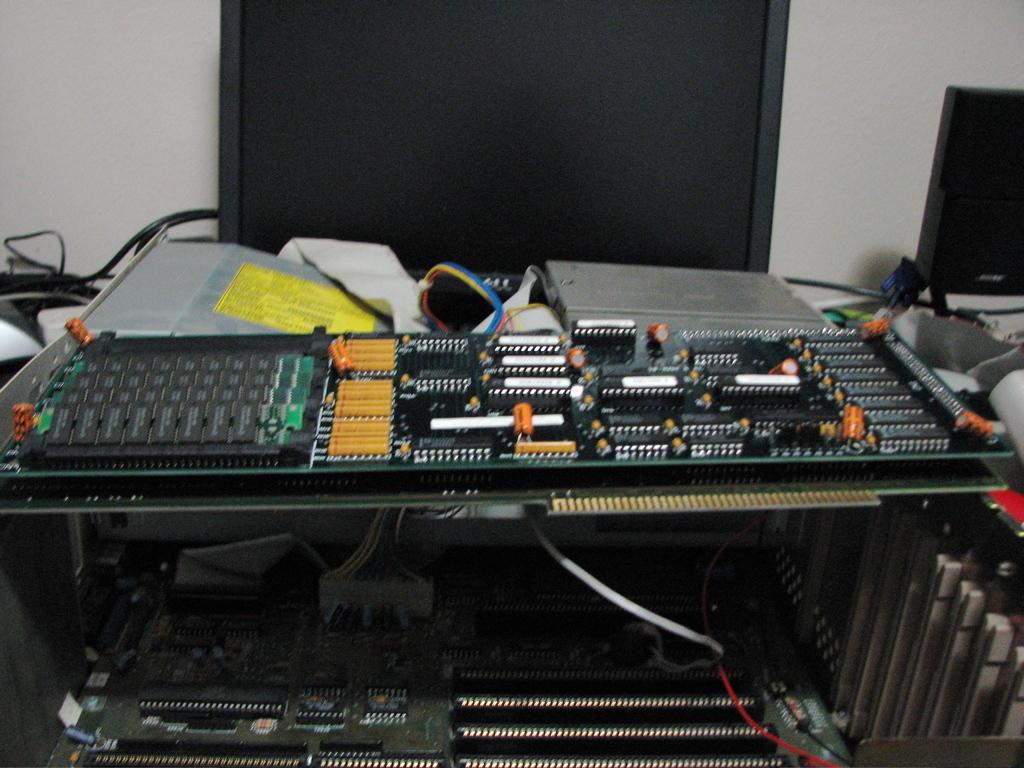What type of devices are present in the image? There are televisions and other electronic items in the image. What can be seen behind the electronic items? There is a wall visible in the image. Where is the mom in the image? There is no mom present in the image. What type of birds can be seen on the wall in the image? There are no birds, specifically geese, present on the wall in the image. 